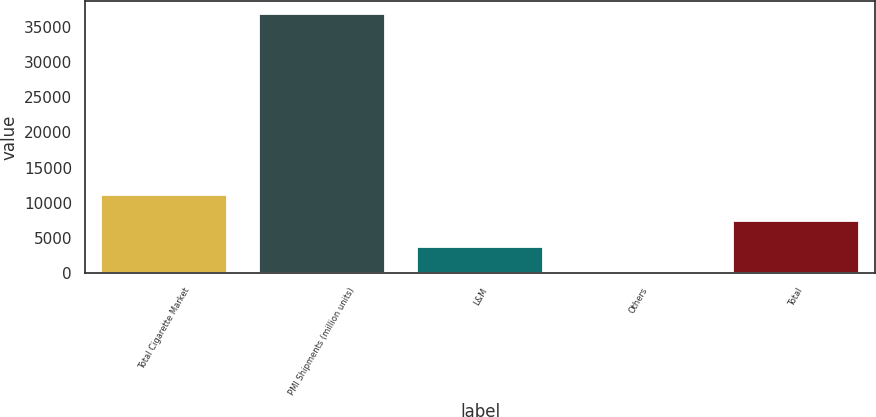Convert chart. <chart><loc_0><loc_0><loc_500><loc_500><bar_chart><fcel>Total Cigarette Market<fcel>PMI Shipments (million units)<fcel>L&M<fcel>Others<fcel>Total<nl><fcel>11056.2<fcel>36849<fcel>3686.79<fcel>2.1<fcel>7371.48<nl></chart> 